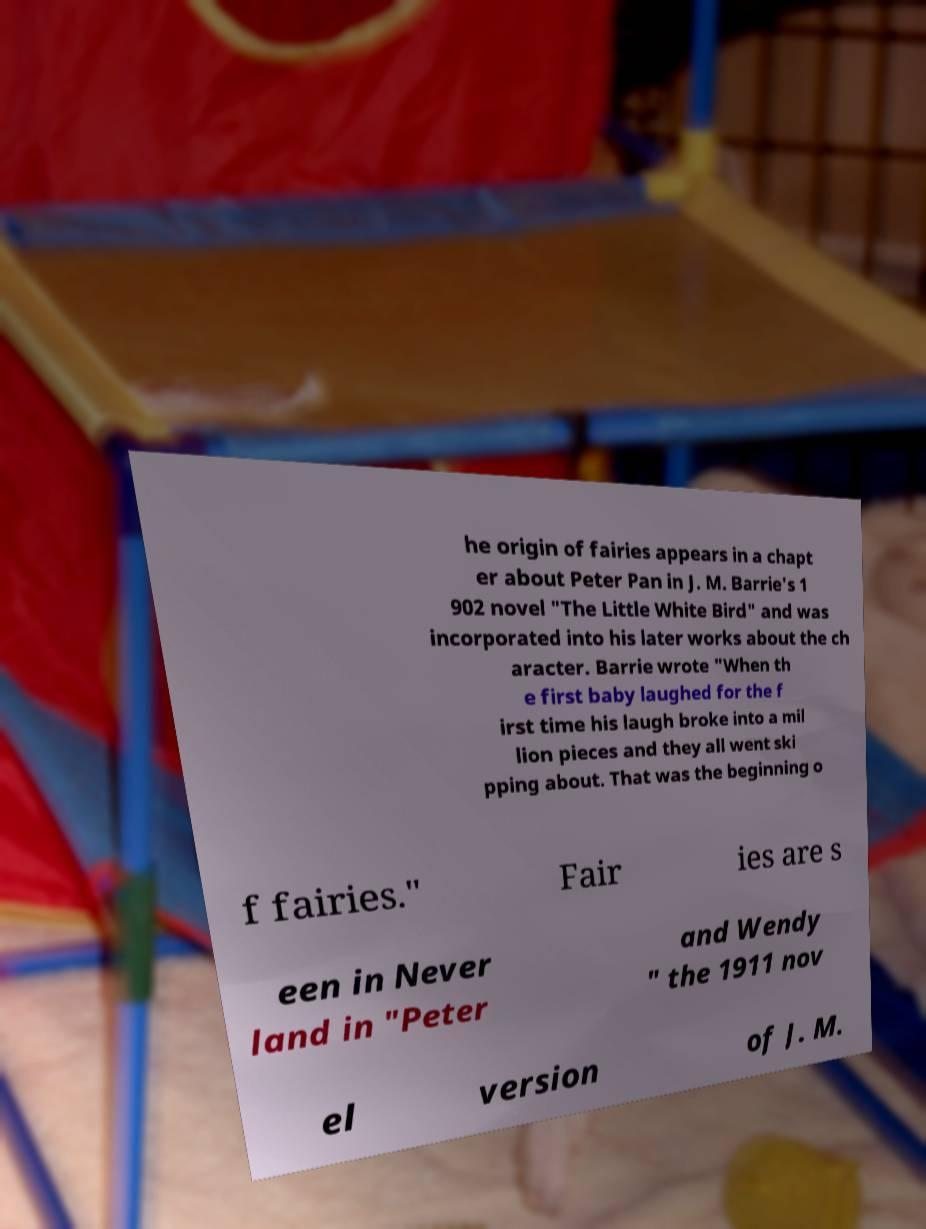Can you read and provide the text displayed in the image?This photo seems to have some interesting text. Can you extract and type it out for me? he origin of fairies appears in a chapt er about Peter Pan in J. M. Barrie's 1 902 novel "The Little White Bird" and was incorporated into his later works about the ch aracter. Barrie wrote "When th e first baby laughed for the f irst time his laugh broke into a mil lion pieces and they all went ski pping about. That was the beginning o f fairies." Fair ies are s een in Never land in "Peter and Wendy " the 1911 nov el version of J. M. 